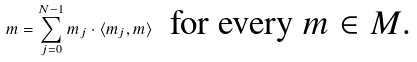<formula> <loc_0><loc_0><loc_500><loc_500>m = \sum _ { j = 0 } ^ { N - 1 } m _ { j } \cdot \langle m _ { j } , m \rangle \ \text { for every $m\in M$.}</formula> 